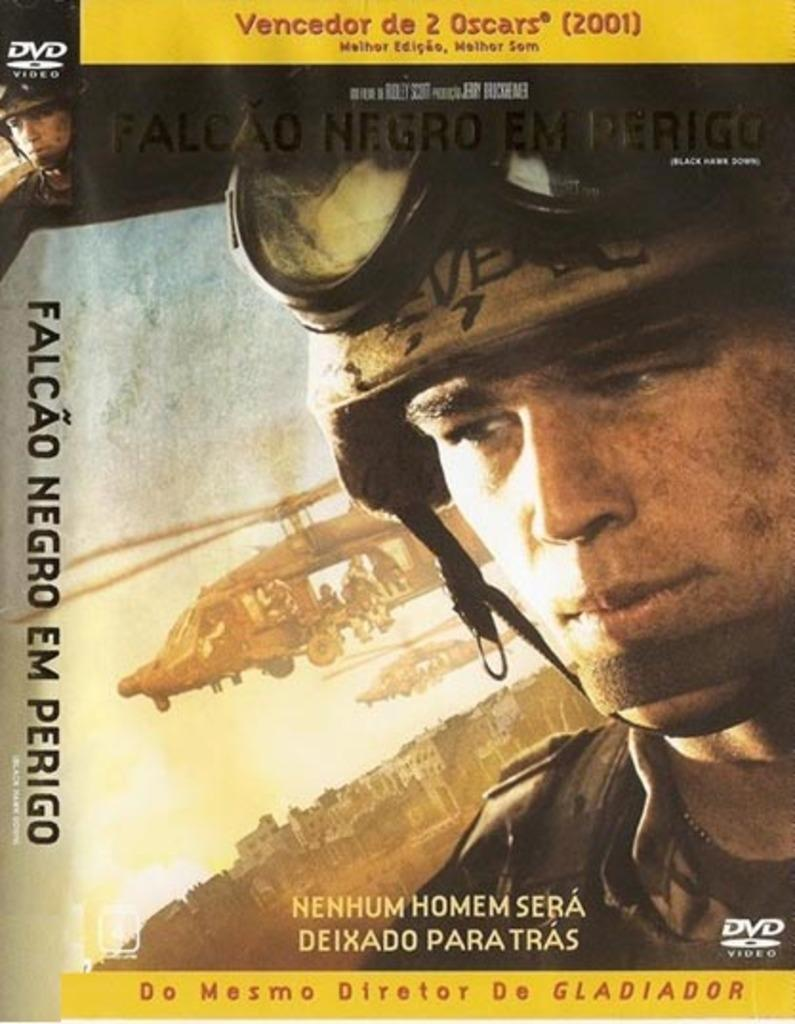<image>
Write a terse but informative summary of the picture. A DVD case for a film in a foreign language that says Do Mesmo Diretor. 